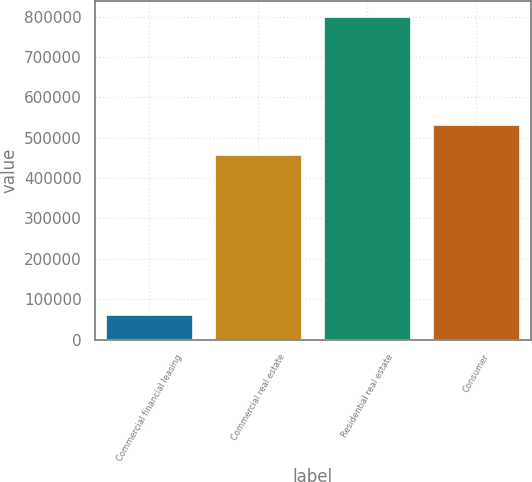Convert chart. <chart><loc_0><loc_0><loc_500><loc_500><bar_chart><fcel>Commercial financial leasing<fcel>Commercial real estate<fcel>Residential real estate<fcel>Consumer<nl><fcel>59928<fcel>456820<fcel>799802<fcel>530807<nl></chart> 